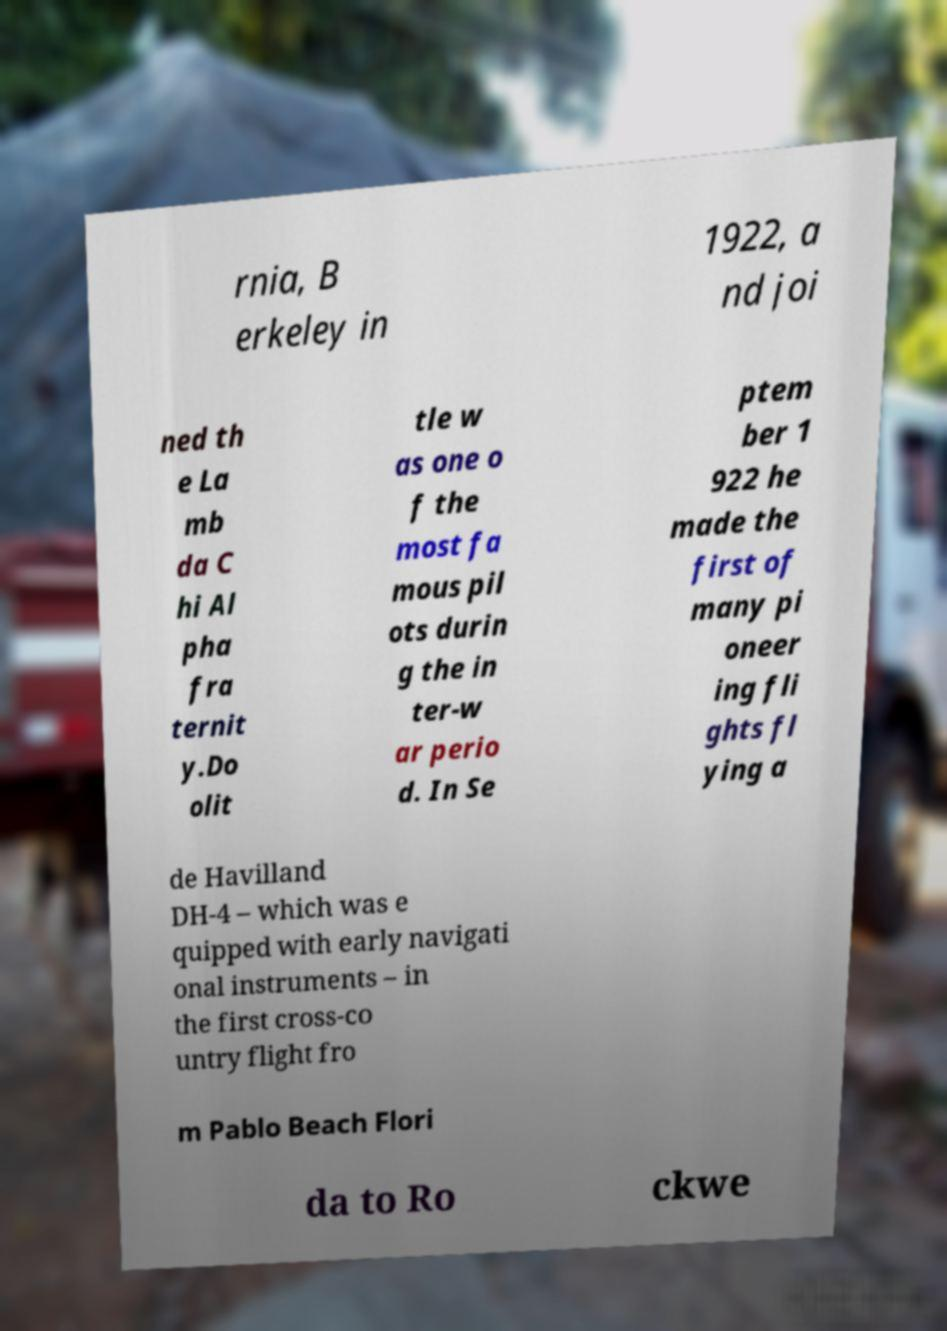Please read and relay the text visible in this image. What does it say? rnia, B erkeley in 1922, a nd joi ned th e La mb da C hi Al pha fra ternit y.Do olit tle w as one o f the most fa mous pil ots durin g the in ter-w ar perio d. In Se ptem ber 1 922 he made the first of many pi oneer ing fli ghts fl ying a de Havilland DH-4 – which was e quipped with early navigati onal instruments – in the first cross-co untry flight fro m Pablo Beach Flori da to Ro ckwe 